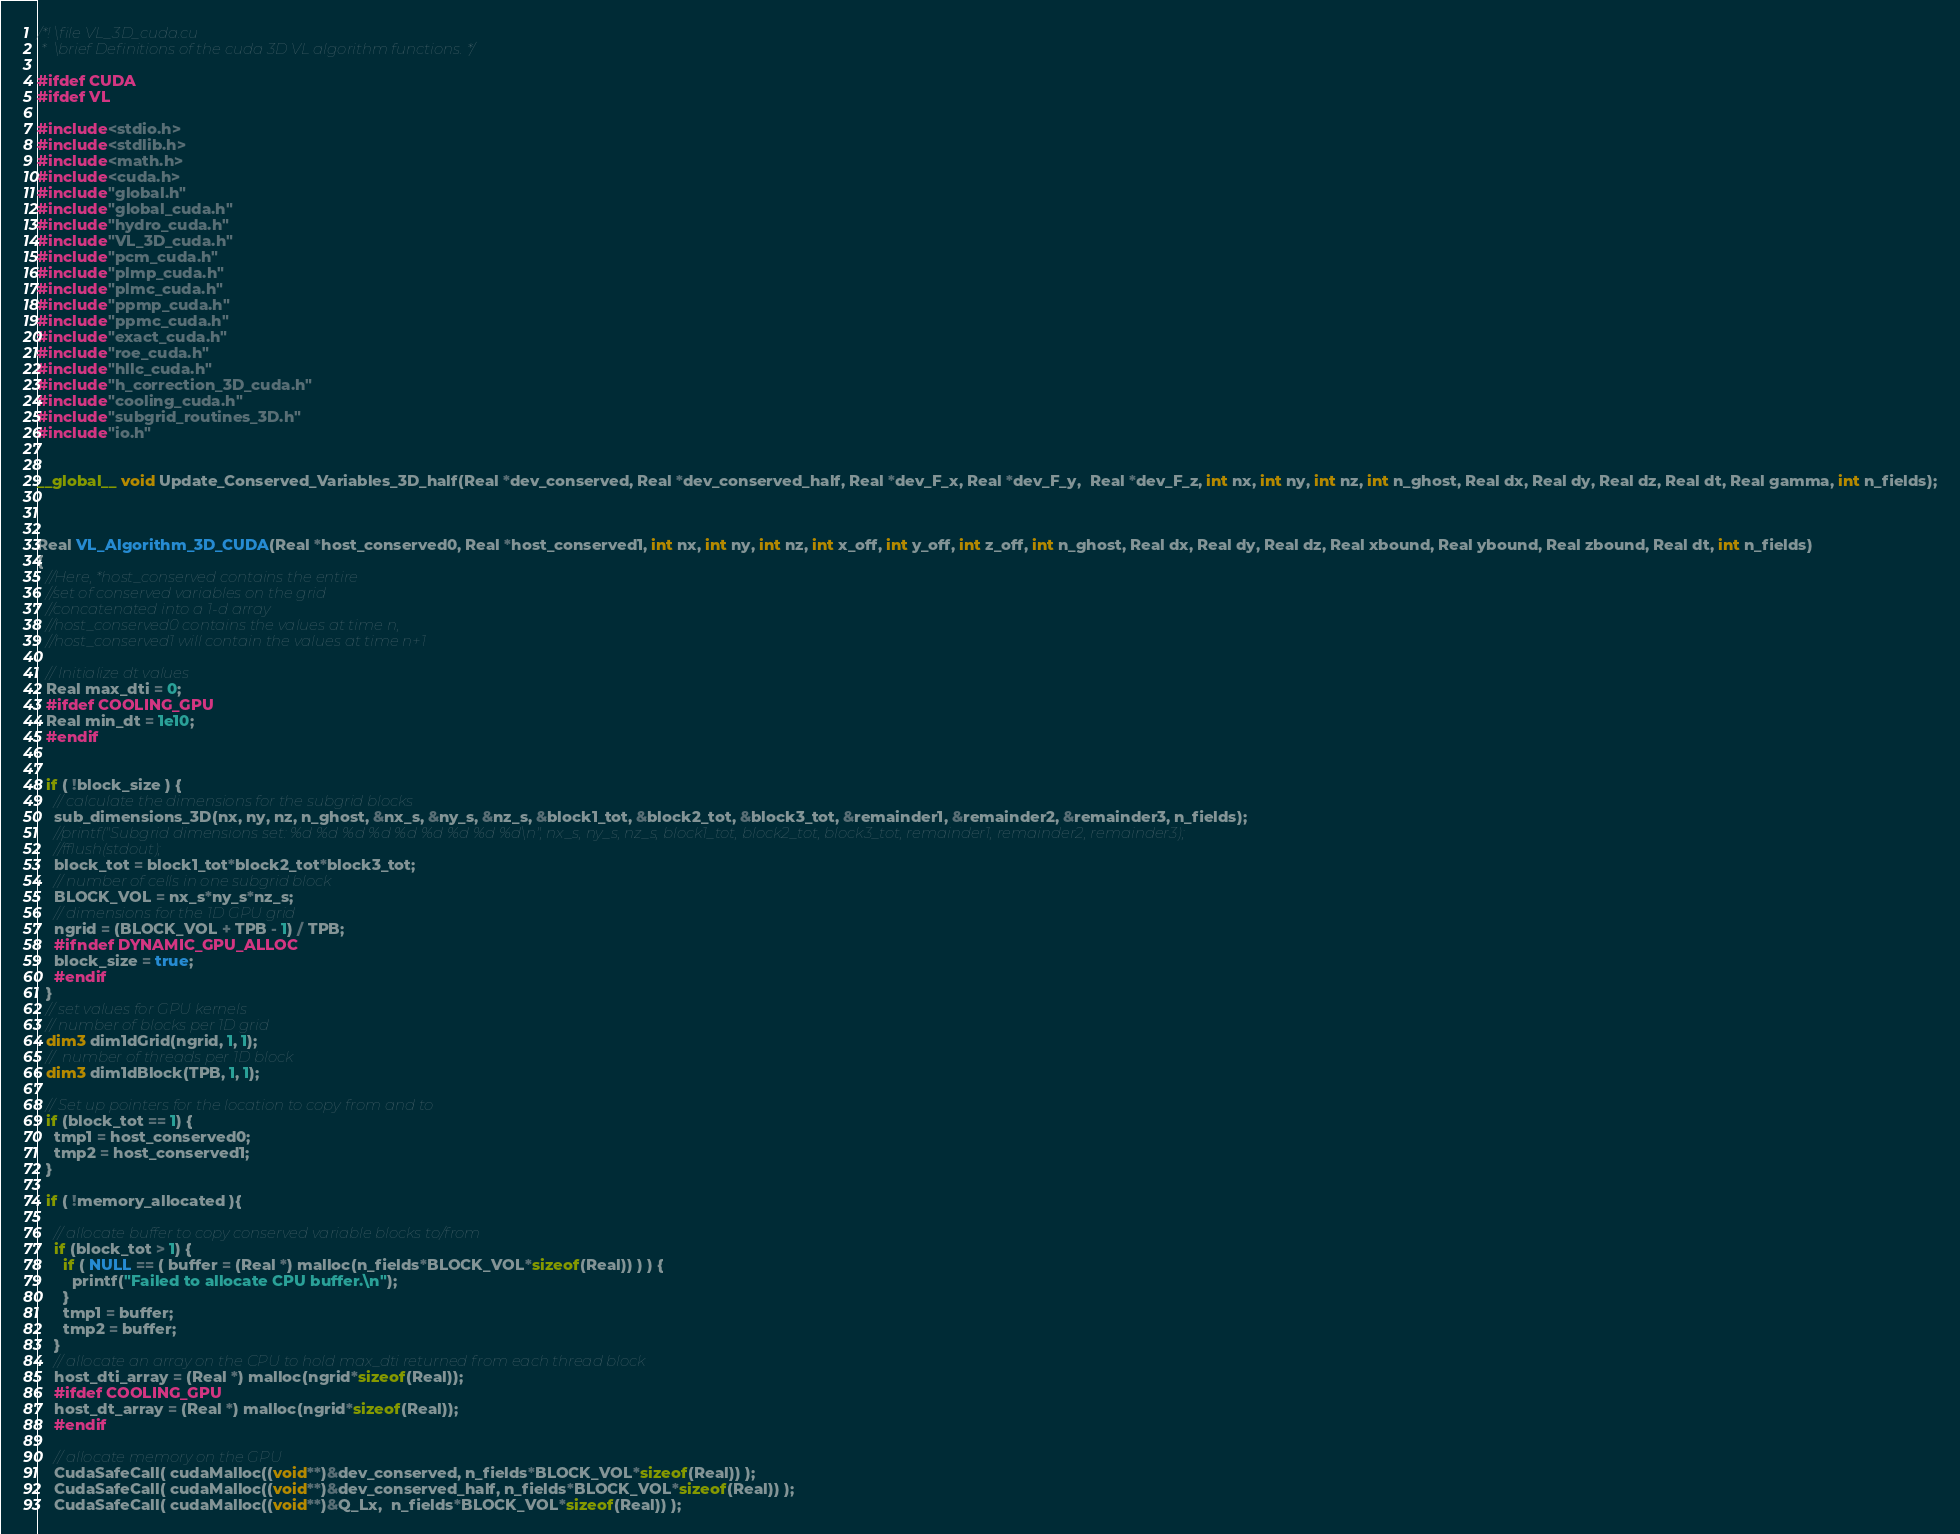<code> <loc_0><loc_0><loc_500><loc_500><_Cuda_>/*! \file VL_3D_cuda.cu
 *  \brief Definitions of the cuda 3D VL algorithm functions. */

#ifdef CUDA
#ifdef VL

#include<stdio.h>
#include<stdlib.h>
#include<math.h>
#include<cuda.h>
#include"global.h"
#include"global_cuda.h"
#include"hydro_cuda.h"
#include"VL_3D_cuda.h"
#include"pcm_cuda.h"
#include"plmp_cuda.h"
#include"plmc_cuda.h"
#include"ppmp_cuda.h"
#include"ppmc_cuda.h"
#include"exact_cuda.h"
#include"roe_cuda.h"
#include"hllc_cuda.h"
#include"h_correction_3D_cuda.h"
#include"cooling_cuda.h"
#include"subgrid_routines_3D.h"
#include"io.h"


__global__ void Update_Conserved_Variables_3D_half(Real *dev_conserved, Real *dev_conserved_half, Real *dev_F_x, Real *dev_F_y,  Real *dev_F_z, int nx, int ny, int nz, int n_ghost, Real dx, Real dy, Real dz, Real dt, Real gamma, int n_fields);



Real VL_Algorithm_3D_CUDA(Real *host_conserved0, Real *host_conserved1, int nx, int ny, int nz, int x_off, int y_off, int z_off, int n_ghost, Real dx, Real dy, Real dz, Real xbound, Real ybound, Real zbound, Real dt, int n_fields)
{
  //Here, *host_conserved contains the entire
  //set of conserved variables on the grid
  //concatenated into a 1-d array
  //host_conserved0 contains the values at time n,
  //host_conserved1 will contain the values at time n+1

  // Initialize dt values 
  Real max_dti = 0;
  #ifdef COOLING_GPU
  Real min_dt = 1e10;
  #endif  


  if ( !block_size ) {
    // calculate the dimensions for the subgrid blocks
    sub_dimensions_3D(nx, ny, nz, n_ghost, &nx_s, &ny_s, &nz_s, &block1_tot, &block2_tot, &block3_tot, &remainder1, &remainder2, &remainder3, n_fields);
    //printf("Subgrid dimensions set: %d %d %d %d %d %d %d %d %d\n", nx_s, ny_s, nz_s, block1_tot, block2_tot, block3_tot, remainder1, remainder2, remainder3);
    //fflush(stdout);
    block_tot = block1_tot*block2_tot*block3_tot;
    // number of cells in one subgrid block
    BLOCK_VOL = nx_s*ny_s*nz_s;
    // dimensions for the 1D GPU grid
    ngrid = (BLOCK_VOL + TPB - 1) / TPB;
    #ifndef DYNAMIC_GPU_ALLOC
    block_size = true;
    #endif
  }
  // set values for GPU kernels
  // number of blocks per 1D grid  
  dim3 dim1dGrid(ngrid, 1, 1);
  //  number of threads per 1D block   
  dim3 dim1dBlock(TPB, 1, 1);

  // Set up pointers for the location to copy from and to
  if (block_tot == 1) {
    tmp1 = host_conserved0;
    tmp2 = host_conserved1;
  }

  if ( !memory_allocated ){

    // allocate buffer to copy conserved variable blocks to/from
    if (block_tot > 1) {
      if ( NULL == ( buffer = (Real *) malloc(n_fields*BLOCK_VOL*sizeof(Real)) ) ) {
        printf("Failed to allocate CPU buffer.\n");
      }
      tmp1 = buffer;
      tmp2 = buffer;
    }
    // allocate an array on the CPU to hold max_dti returned from each thread block
    host_dti_array = (Real *) malloc(ngrid*sizeof(Real));
    #ifdef COOLING_GPU
    host_dt_array = (Real *) malloc(ngrid*sizeof(Real));
    #endif  

    // allocate memory on the GPU
    CudaSafeCall( cudaMalloc((void**)&dev_conserved, n_fields*BLOCK_VOL*sizeof(Real)) );
    CudaSafeCall( cudaMalloc((void**)&dev_conserved_half, n_fields*BLOCK_VOL*sizeof(Real)) );
    CudaSafeCall( cudaMalloc((void**)&Q_Lx,  n_fields*BLOCK_VOL*sizeof(Real)) );</code> 